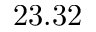<formula> <loc_0><loc_0><loc_500><loc_500>2 3 . 3 2</formula> 